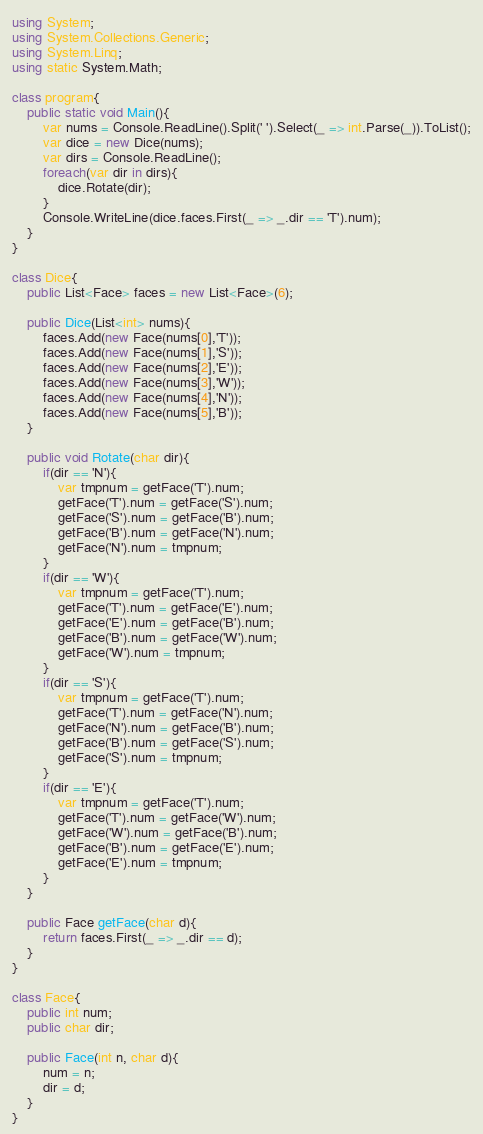<code> <loc_0><loc_0><loc_500><loc_500><_C#_>using System;
using System.Collections.Generic;
using System.Linq;
using static System.Math;

class program{
    public static void Main(){
        var nums = Console.ReadLine().Split(' ').Select(_ => int.Parse(_)).ToList();
        var dice = new Dice(nums);
        var dirs = Console.ReadLine();
        foreach(var dir in dirs){
            dice.Rotate(dir);
        }
        Console.WriteLine(dice.faces.First(_ => _.dir == 'T').num);
    }
}

class Dice{
    public List<Face> faces = new List<Face>(6);

    public Dice(List<int> nums){
        faces.Add(new Face(nums[0],'T'));
        faces.Add(new Face(nums[1],'S'));
        faces.Add(new Face(nums[2],'E'));
        faces.Add(new Face(nums[3],'W'));
        faces.Add(new Face(nums[4],'N'));
        faces.Add(new Face(nums[5],'B'));
    }

    public void Rotate(char dir){
        if(dir == 'N'){
            var tmpnum = getFace('T').num;
            getFace('T').num = getFace('S').num;
            getFace('S').num = getFace('B').num;
            getFace('B').num = getFace('N').num;
            getFace('N').num = tmpnum;
        }
        if(dir == 'W'){
            var tmpnum = getFace('T').num;
            getFace('T').num = getFace('E').num;
            getFace('E').num = getFace('B').num;
            getFace('B').num = getFace('W').num;
            getFace('W').num = tmpnum;
        }
        if(dir == 'S'){
            var tmpnum = getFace('T').num;
            getFace('T').num = getFace('N').num;
            getFace('N').num = getFace('B').num;
            getFace('B').num = getFace('S').num;
            getFace('S').num = tmpnum;
        }
        if(dir == 'E'){
            var tmpnum = getFace('T').num;
            getFace('T').num = getFace('W').num;
            getFace('W').num = getFace('B').num;
            getFace('B').num = getFace('E').num;
            getFace('E').num = tmpnum;
        }
    }

    public Face getFace(char d){
        return faces.First(_ => _.dir == d);
    }
}

class Face{
    public int num;
    public char dir;

    public Face(int n, char d){
        num = n;
        dir = d;
    }
}

</code> 